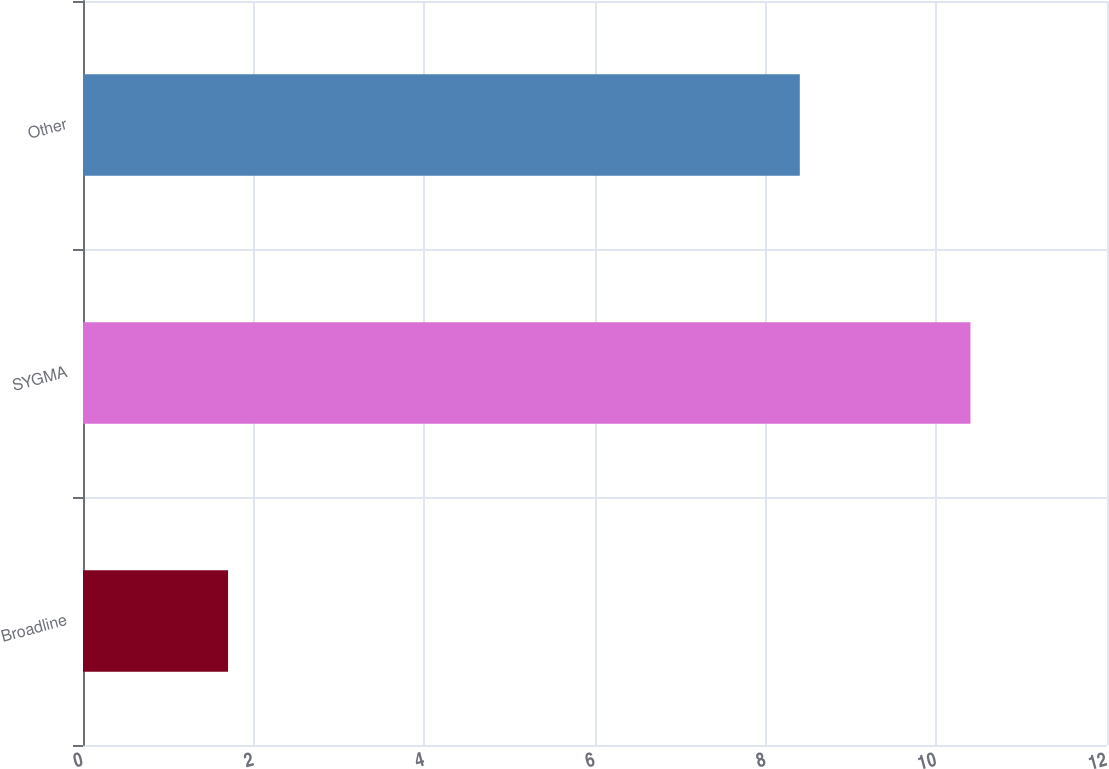Convert chart. <chart><loc_0><loc_0><loc_500><loc_500><bar_chart><fcel>Broadline<fcel>SYGMA<fcel>Other<nl><fcel>1.7<fcel>10.4<fcel>8.4<nl></chart> 